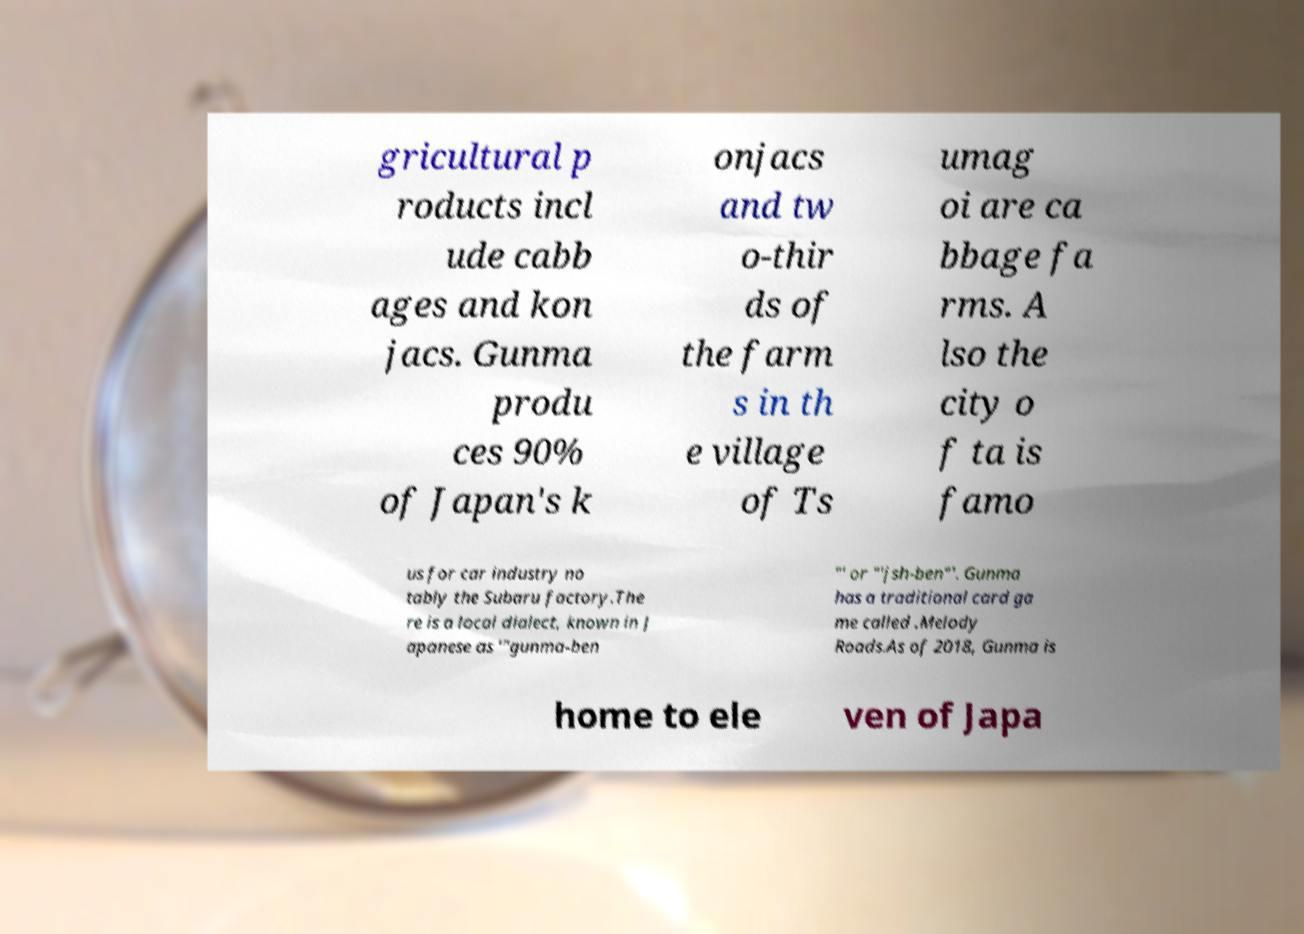Could you extract and type out the text from this image? gricultural p roducts incl ude cabb ages and kon jacs. Gunma produ ces 90% of Japan's k onjacs and tw o-thir ds of the farm s in th e village of Ts umag oi are ca bbage fa rms. A lso the city o f ta is famo us for car industry no tably the Subaru factory.The re is a local dialect, known in J apanese as '"gunma-ben "' or "'jsh-ben"'. Gunma has a traditional card ga me called .Melody Roads.As of 2018, Gunma is home to ele ven of Japa 